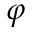Convert formula to latex. <formula><loc_0><loc_0><loc_500><loc_500>\varphi</formula> 